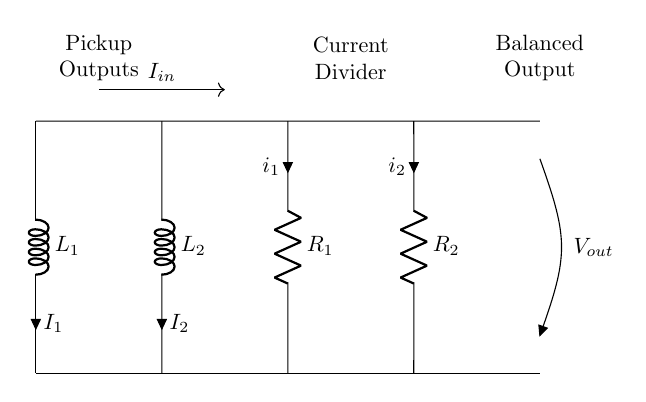What is the type of components labeled as L1 and L2? L1 and L2 are inductors, which are often used in circuits to add inductance. In this circuit, they function as the pickups in electric stringed instruments.
Answer: inductors What current flows into the circuit? The input current is labeled as I_in, indicating the current entering the circuit from the pickups. This is the source current that the circuit uses to distribute between the outputs.
Answer: I_in What does R1 and R2 represent in this circuit? R1 and R2 are resistors, which control the current through each pickup. Their values can affect how much current is divided between the outputs of the pickups.
Answer: resistors How is the output voltage labeled in the circuit? The output voltage is designated as V_out, indicating the voltage available at the output terminals of the current divider circuit. This is the voltage that will be balanced for the instrument's use.
Answer: V_out What is the function of the current divider in this circuit? The current divider's role is to balance the output currents from the pickups L1 and L2 through resistors R1 and R2. This ensures that both pickups contribute equally to the output's sound.
Answer: balance output currents What is the relationship between the currents I1 and I2 in this circuit? The currents I1 and I2 through the inductors L1 and L2 are proportional to the resistances R1 and R2, respectively, following the current divider rule which states that the current divides inversely with resistance.
Answer: proportional to resistances What is the significance of the labels in the circuit diagram? The labels provide important information about each component's role and the direction of current flow. They indicate how the circuit should be understood and how signals will interact within it.
Answer: important for understanding circuit interactions 